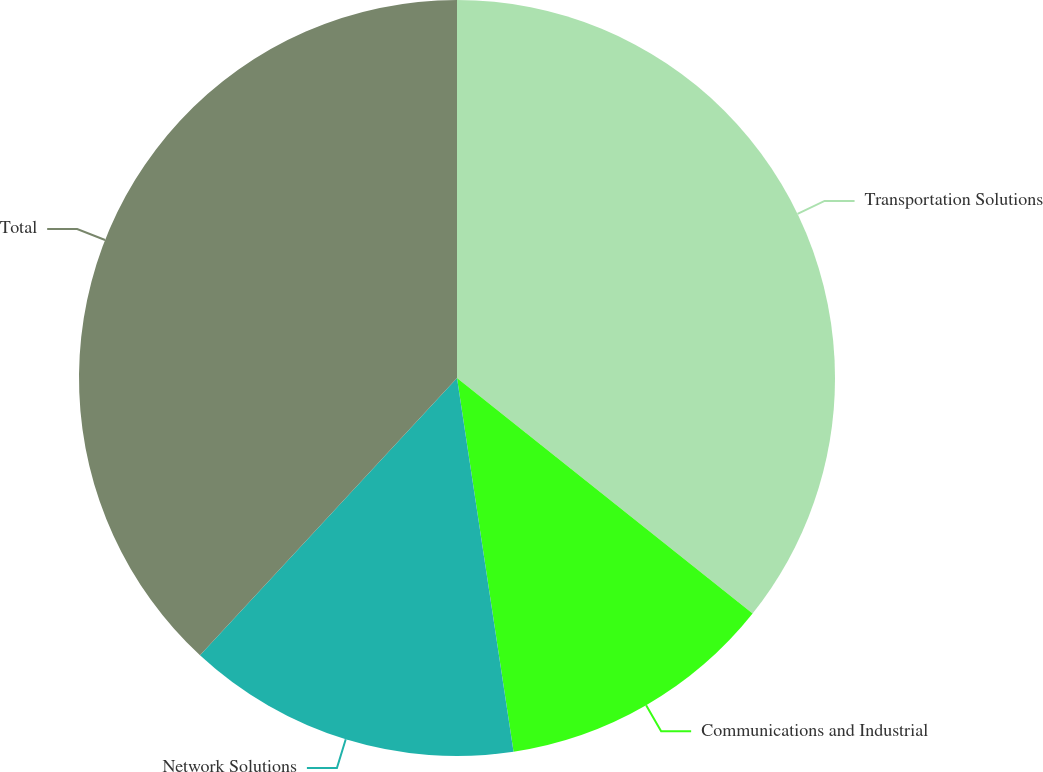Convert chart. <chart><loc_0><loc_0><loc_500><loc_500><pie_chart><fcel>Transportation Solutions<fcel>Communications and Industrial<fcel>Network Solutions<fcel>Total<nl><fcel>35.71%<fcel>11.9%<fcel>14.29%<fcel>38.1%<nl></chart> 